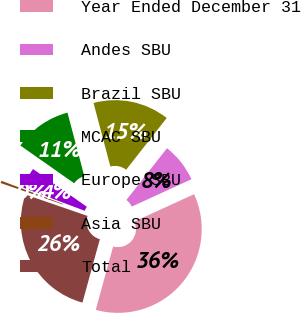Convert chart to OTSL. <chart><loc_0><loc_0><loc_500><loc_500><pie_chart><fcel>Year Ended December 31<fcel>Andes SBU<fcel>Brazil SBU<fcel>MCAC SBU<fcel>Europe SBU<fcel>Asia SBU<fcel>Total<nl><fcel>36.1%<fcel>7.58%<fcel>14.71%<fcel>11.14%<fcel>4.01%<fcel>0.45%<fcel>26.01%<nl></chart> 